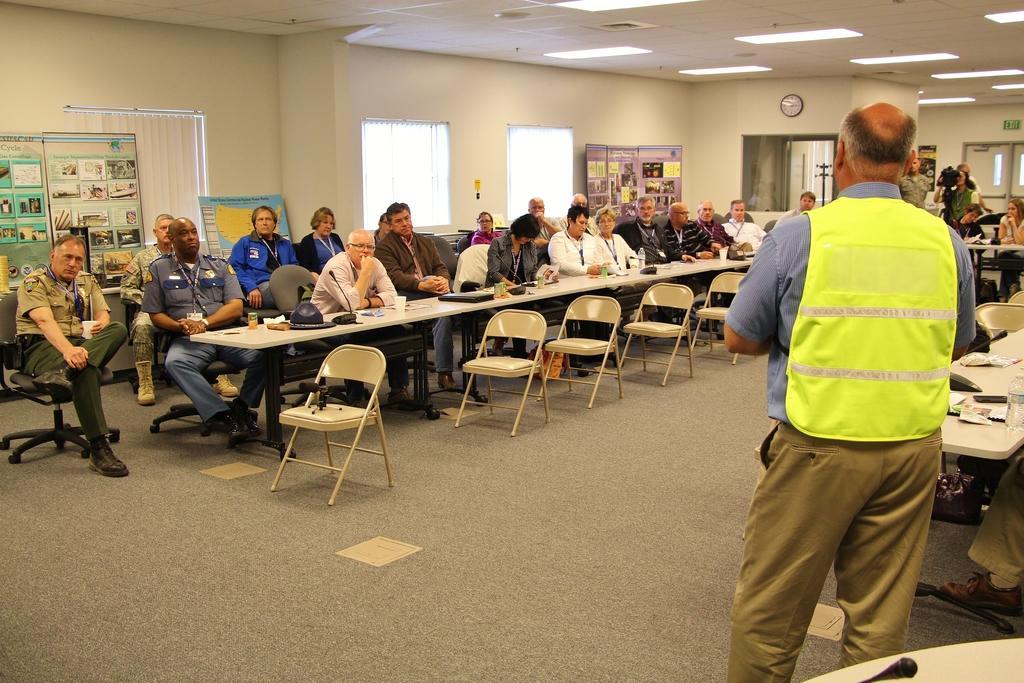Could you give a brief overview of what you see in this image? I can see in this image group of people are sitting on a chair in front of a table and the person is standing on the ground. There are also few empty chairs. On the table we have some objects on it. In the background I can see there are two windows and a clock on a wall. 